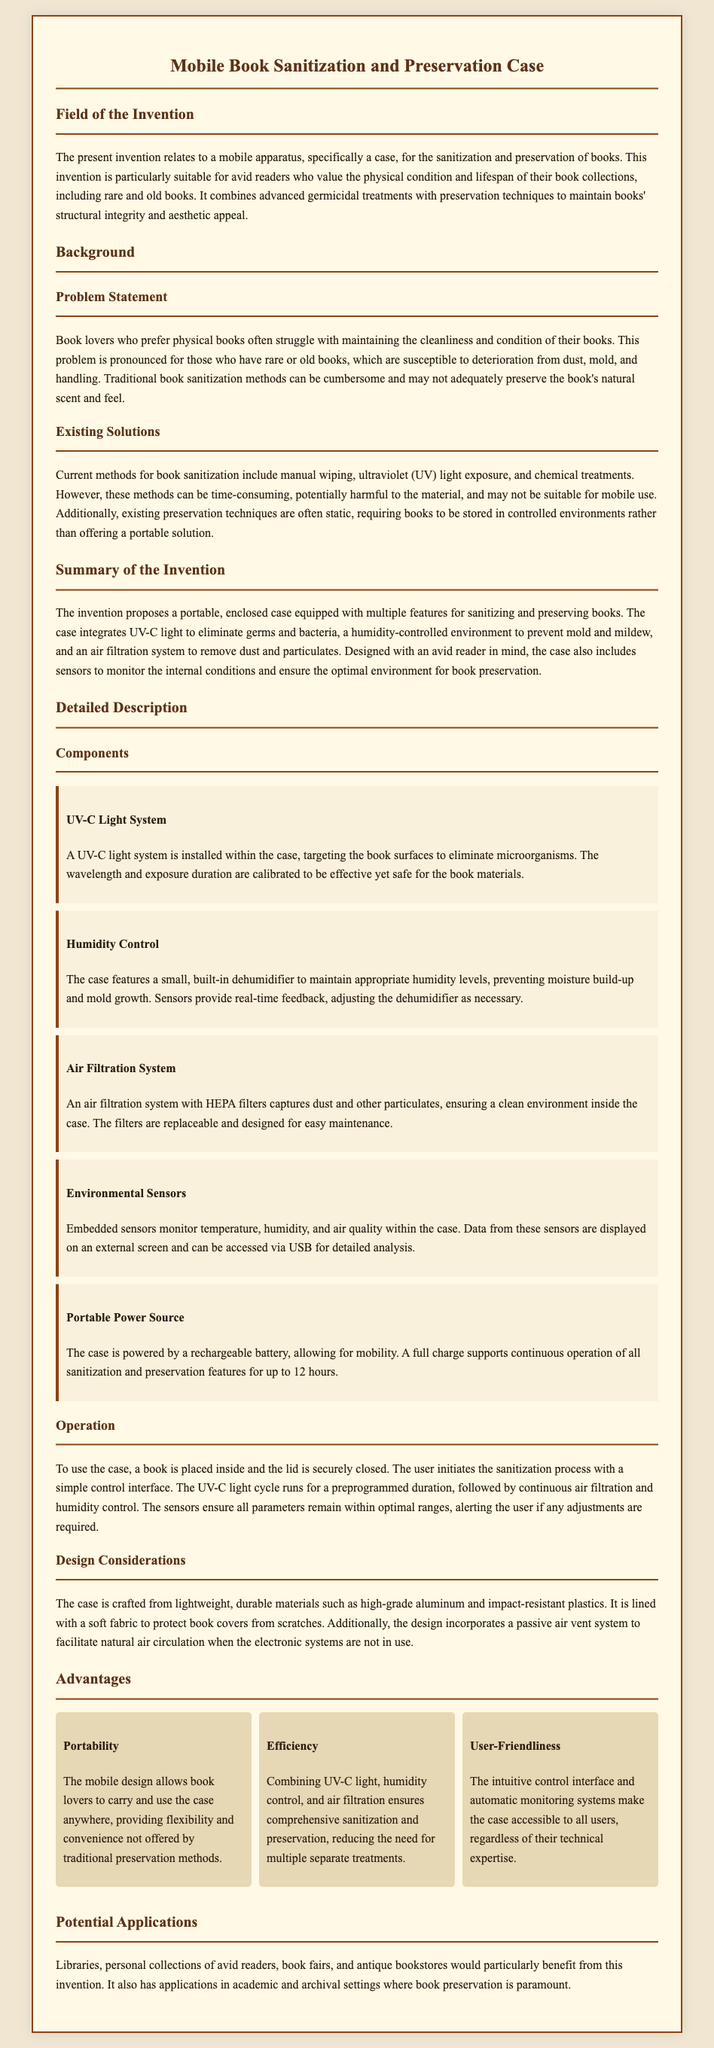What is the primary function of the invention? The invention relates to a mobile apparatus for the sanitization and preservation of books.
Answer: sanitization and preservation What methods are mentioned as current solutions for book sanitization? The document lists manual wiping, ultraviolet (UV) light exposure, and chemical treatments as current methods.
Answer: manual wiping, ultraviolet light exposure, chemical treatments What feature ensures the case remains mobile? The mobility of the case is supported by the inclusion of a portable power source.
Answer: rechargeable battery What is the maximum operation time on a full charge? The case provides continuous operation for up to 12 hours on a full charge.
Answer: 12 hours How does the humidity control prevent mold growth? A built-in dehumidifier maintains appropriate humidity levels to prevent moisture buildup.
Answer: built-in dehumidifier What specific audiences can benefit from this invention? The potential applications include libraries, personal collections, book fairs, and antique bookstores.
Answer: libraries, personal collections, book fairs, antique bookstores Which component monitors the internal conditions of the case? Environmental sensors are the components that monitor temperature, humidity, and air quality.
Answer: Environmental sensors What is the purpose of the UV-C light system? The UV-C light system is installed to eliminate microorganisms from the book surfaces.
Answer: eliminate microorganisms What are the advantages listed in the document? The advantages include portability, efficiency, and user-friendliness.
Answer: portability, efficiency, user-friendliness 